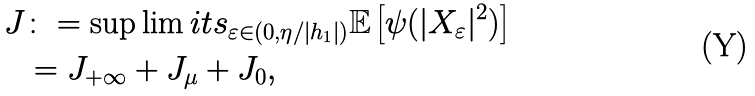<formula> <loc_0><loc_0><loc_500><loc_500>J & \colon = \sup \lim i t s _ { \varepsilon \in ( 0 , \eta / | h _ { 1 } | ) } \mathbb { E } \left [ \psi ( | X _ { \varepsilon } | ^ { 2 } ) \right ] \\ & = J _ { + \infty } + J _ { \mu } + J _ { 0 } ,</formula> 